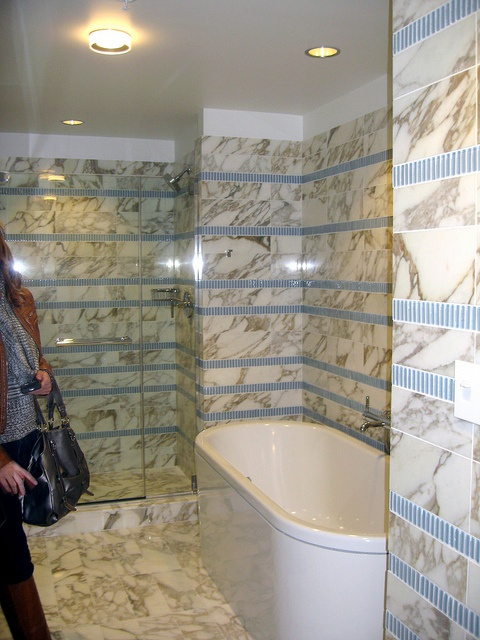Describe the objects in this image and their specific colors. I can see people in gray, black, maroon, and brown tones, handbag in gray, black, and darkgreen tones, and cell phone in gray and black tones in this image. 